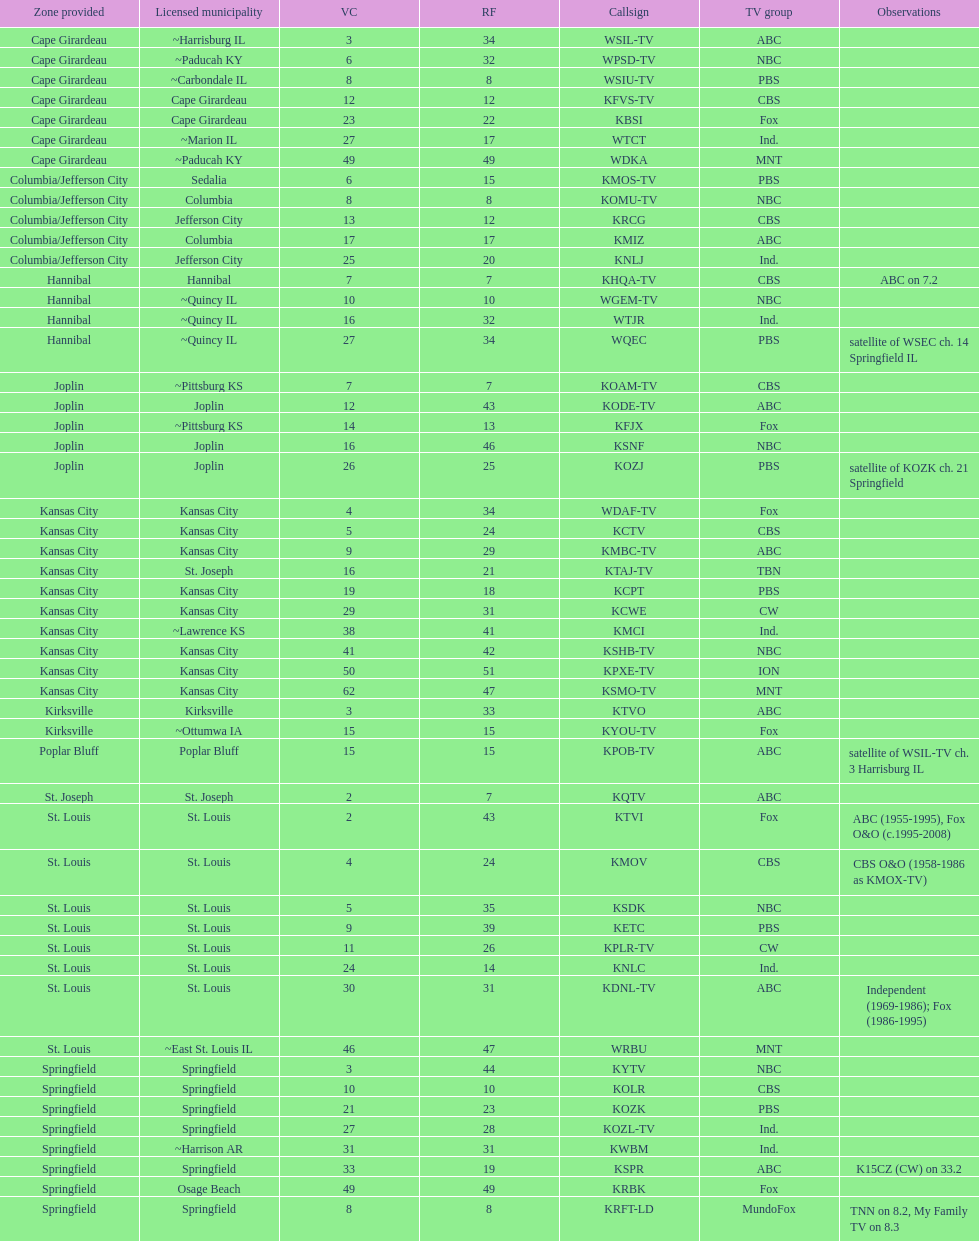How many television stations serve the cape girardeau area? 7. 